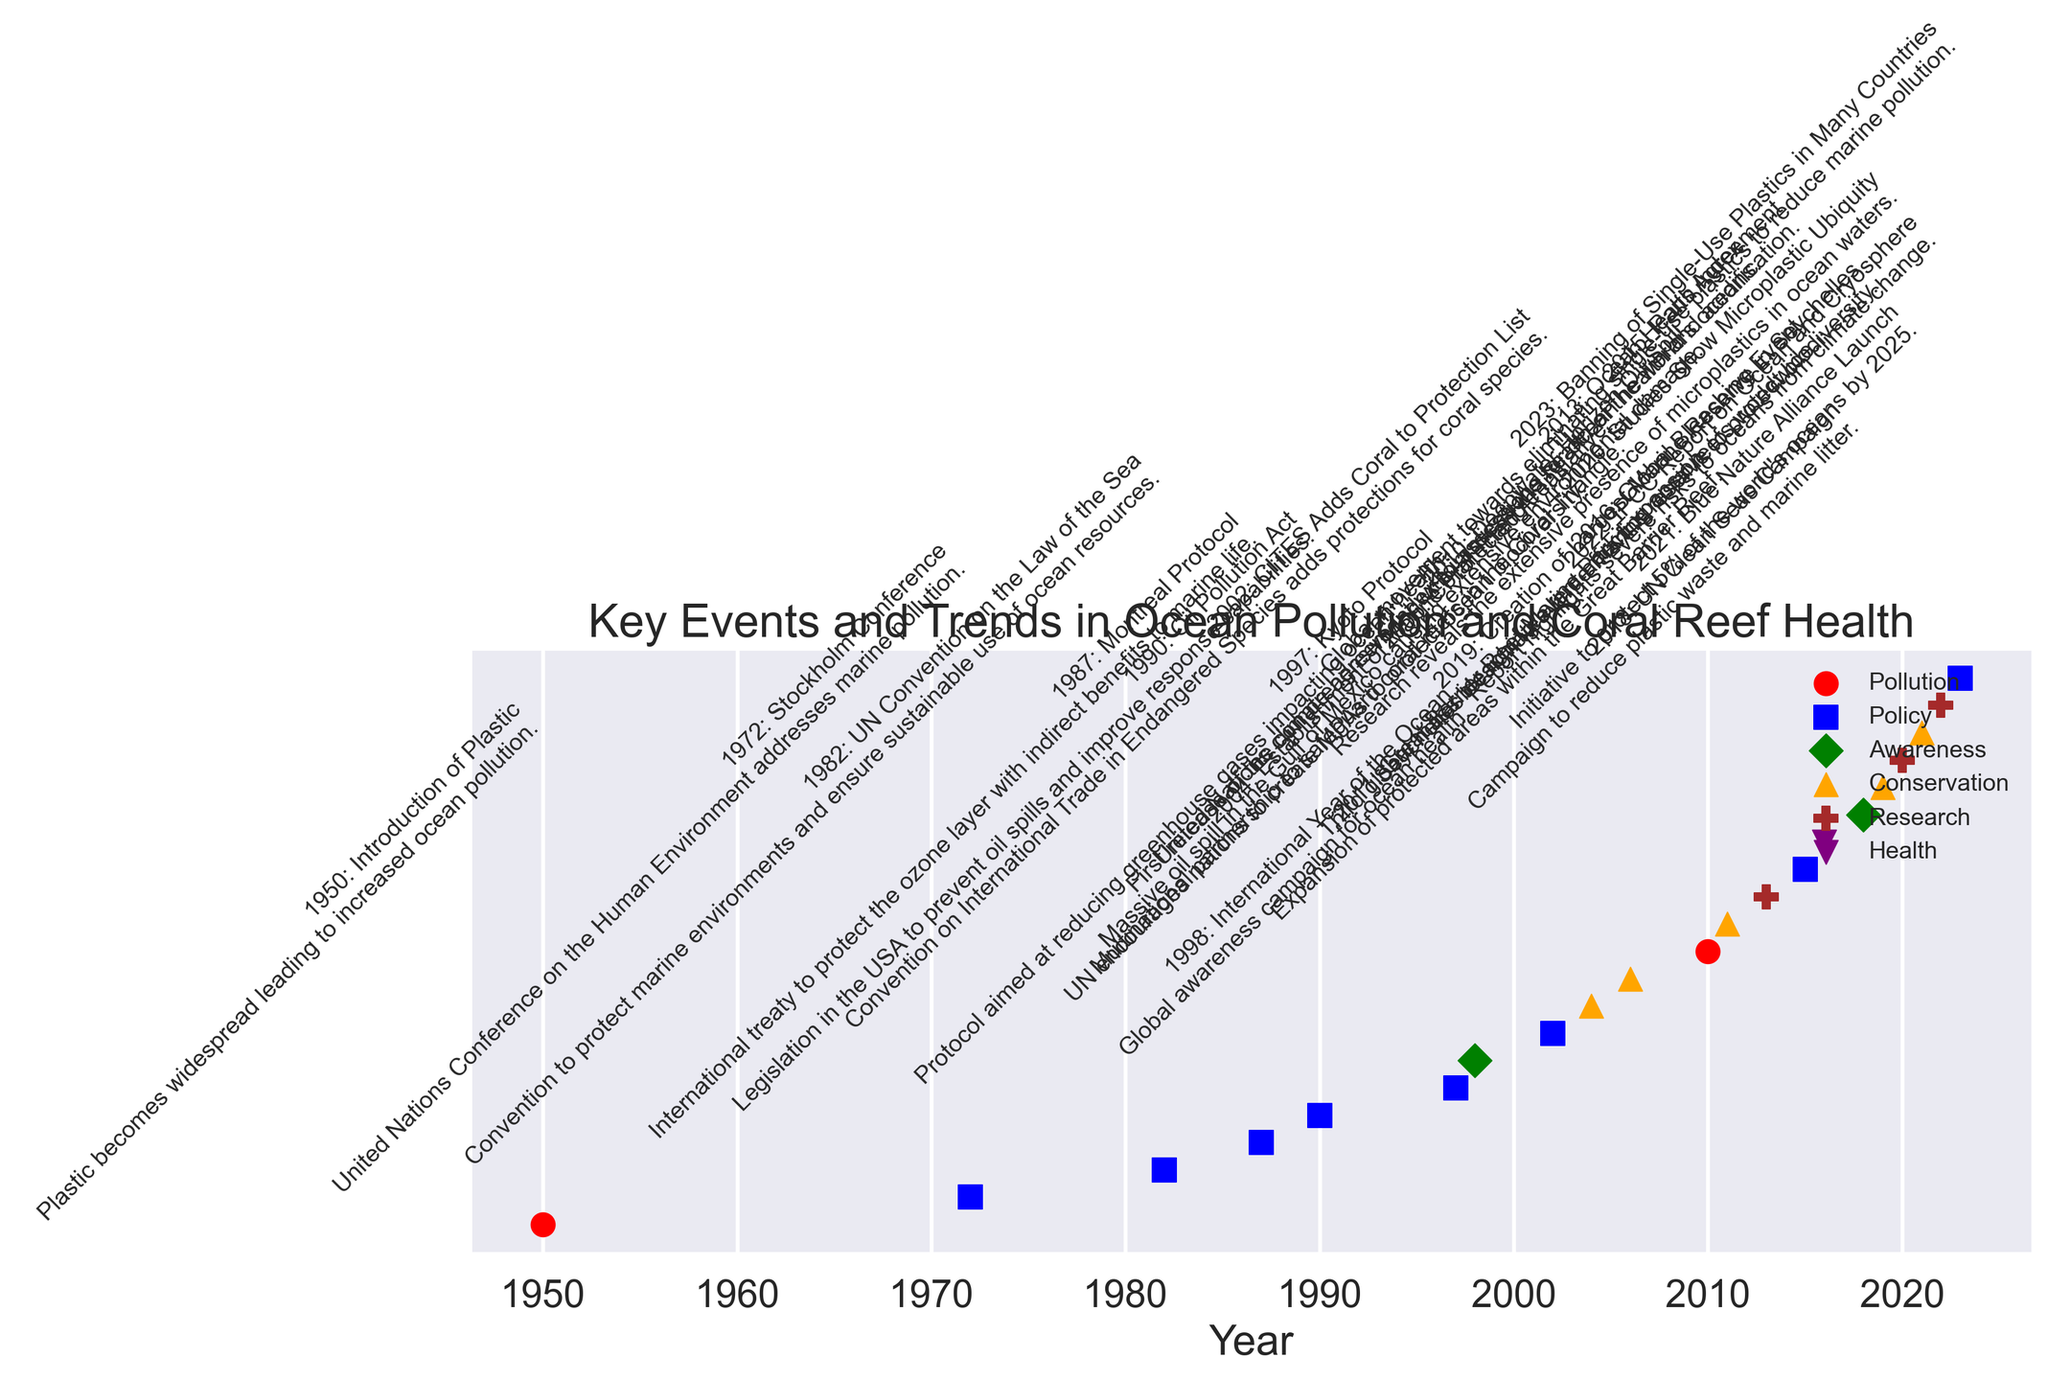What major pollution event occurred in 2010? To find the major pollution event in 2010, look for the event marked with a red circle (representing pollution) in the year 2010. The event is labeled "Deepwater Horizon Oil Spill".
Answer: Deepwater Horizon Oil Spill Which two categories had events related to coral reefs? Look for events mentioning coral reefs in their details and identify their categories by color and marker. "CITES Adds Coral to Protection List", a blue square (policy), and "Global Bleaching Event", a purple downward triangle (health), are related to coral reefs.
Answer: Policy and Health How many events were categorized as "Policy"? Identify the number of events marked with a blue square, which represents the policy category. Count the labels with blue squares: there are 7 such events.
Answer: 7 Which category has the first recorded event, and what is the event? The first event on the time axis is in 1950. Look for the marker that aligns with this year. It is a red circle (pollution), labeled "Introduction of Plastic".
Answer: Pollution, Introduction of Plastic What events occurred between 2000 and 2010 and in which categories do they fall? Look for events between 2000 and 2010. They are "Establishment of Marine Protected Areas" (orange triangle, Conservation), "Coral Triangle Initiative" (orange triangle, Conservation), and "Deepwater Horizon Oil Spill" (red circle, Pollution).
Answer: Establishment of Marine Protected Areas (Conservation), Coral Triangle Initiative (Conservation), Deepwater Horizon Oil Spill (Pollution) Compare the number of events related to pollution and conservation. Which category has more events and by how many? Count events with red circles (pollution) and orange triangles (conservation). Pollution has 3 events, and conservation has 6 events. Subtracting the counts: 6 - 3 = 3. Conservation has 3 more events than pollution.
Answer: Conservation by 3 What is the most recent policy event and in what year? Look for the most recent event marked with a blue square (policy). The latest policy event is "Banning of Single-Use Plastics in Many Countries" in 2023.
Answer: Banning of Single-Use Plastics in Many Countries, 2023 Which event in the "Research" category occurred first and in what year? Find the earliest event with a brown star (research). The earliest research event is "Ocean Health Index" in 2013.
Answer: Ocean Health Index, 2013 